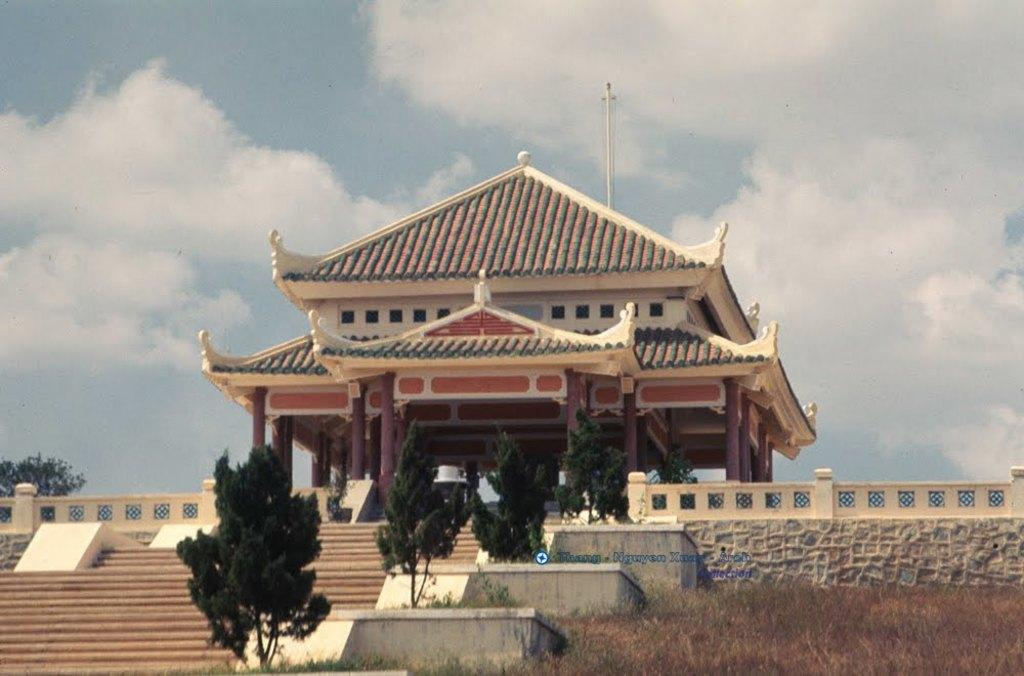What type of structure is visible in the image? There is a building in the image. What architectural feature can be seen in the image? There are stairs in the image. What type of vegetation is present in the image? There are trees in the image. What type of ground cover is visible in the image? There is grass on the ground in the image. How would you describe the sky in the image? The sky is blue and cloudy in the image. What type of quilt is draped over the building in the image? There is no quilt present in the image; it features a building, stairs, trees, grass, and a blue and cloudy sky. 